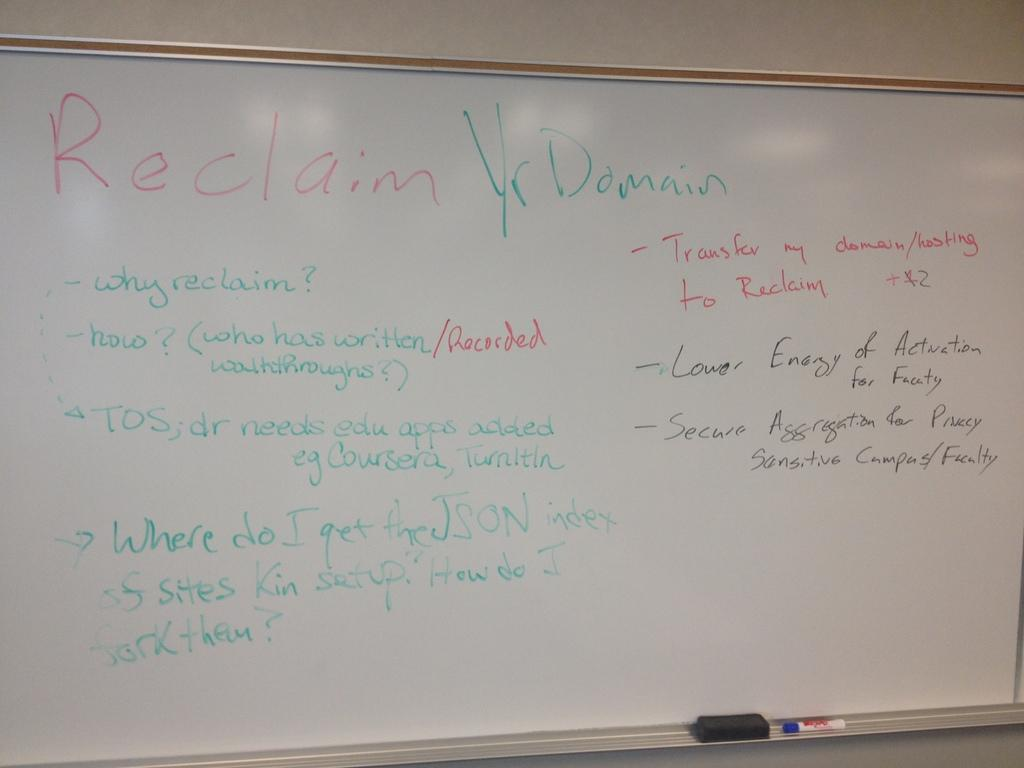<image>
Provide a brief description of the given image. White dry erase board reading reclaim yr domain on the top 